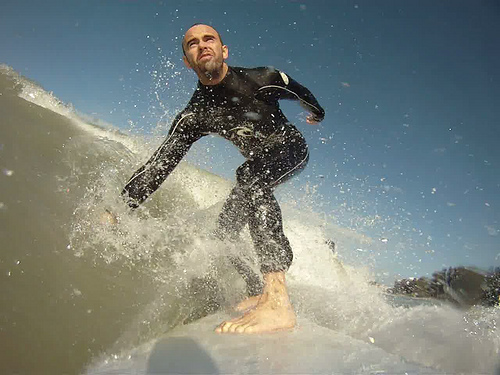What kind of skill level does this surfer display in the image? The surfer depicted in this image demonstrates a high level of skill. His posture, balance, and movement on the surfboard suggest proficiency and confidence in navigating the wave. The positioning of his body, leaning forward with one arm outstretched for balance, indicates experience and an understanding of the wave's dynamics. This level of control and precision is indicative of an advanced or expert surfer who has spent significant time honing their craft. How does the lighting in the image contribute to its overall mood? The lighting in the image plays a critical role in defining its mood. The sunlight, casting a warm and natural glow, enhances the vibrant and energetic atmosphere of the scene. The bright light illuminates the splashing water and creates a vivid contrast against the darker tones of the wetsuit. This lighting not only highlights the details of the surfer's muscles and movement but also evokes a sense of clarity and freshness associated with a bright day out in the ocean. Describe a whimsical, unexpected scenario that could happen next. Just as the surfer rides the crest of the wave, a playful pod of dolphins suddenly appears, leaping in synchronization alongside him. The sight is surreal and magical, as the dolphins effortlessly glide through the water, seeming to join and celebrate his ride. The surfer, initially startled, quickly finds himself laughing and feeling a profound sense of wonder and connection with these magnificent creatures. It's a moment straight out of a dream as he shares the wave with his new marine companions, creating an unforgettable experience etched forever in his memory. 